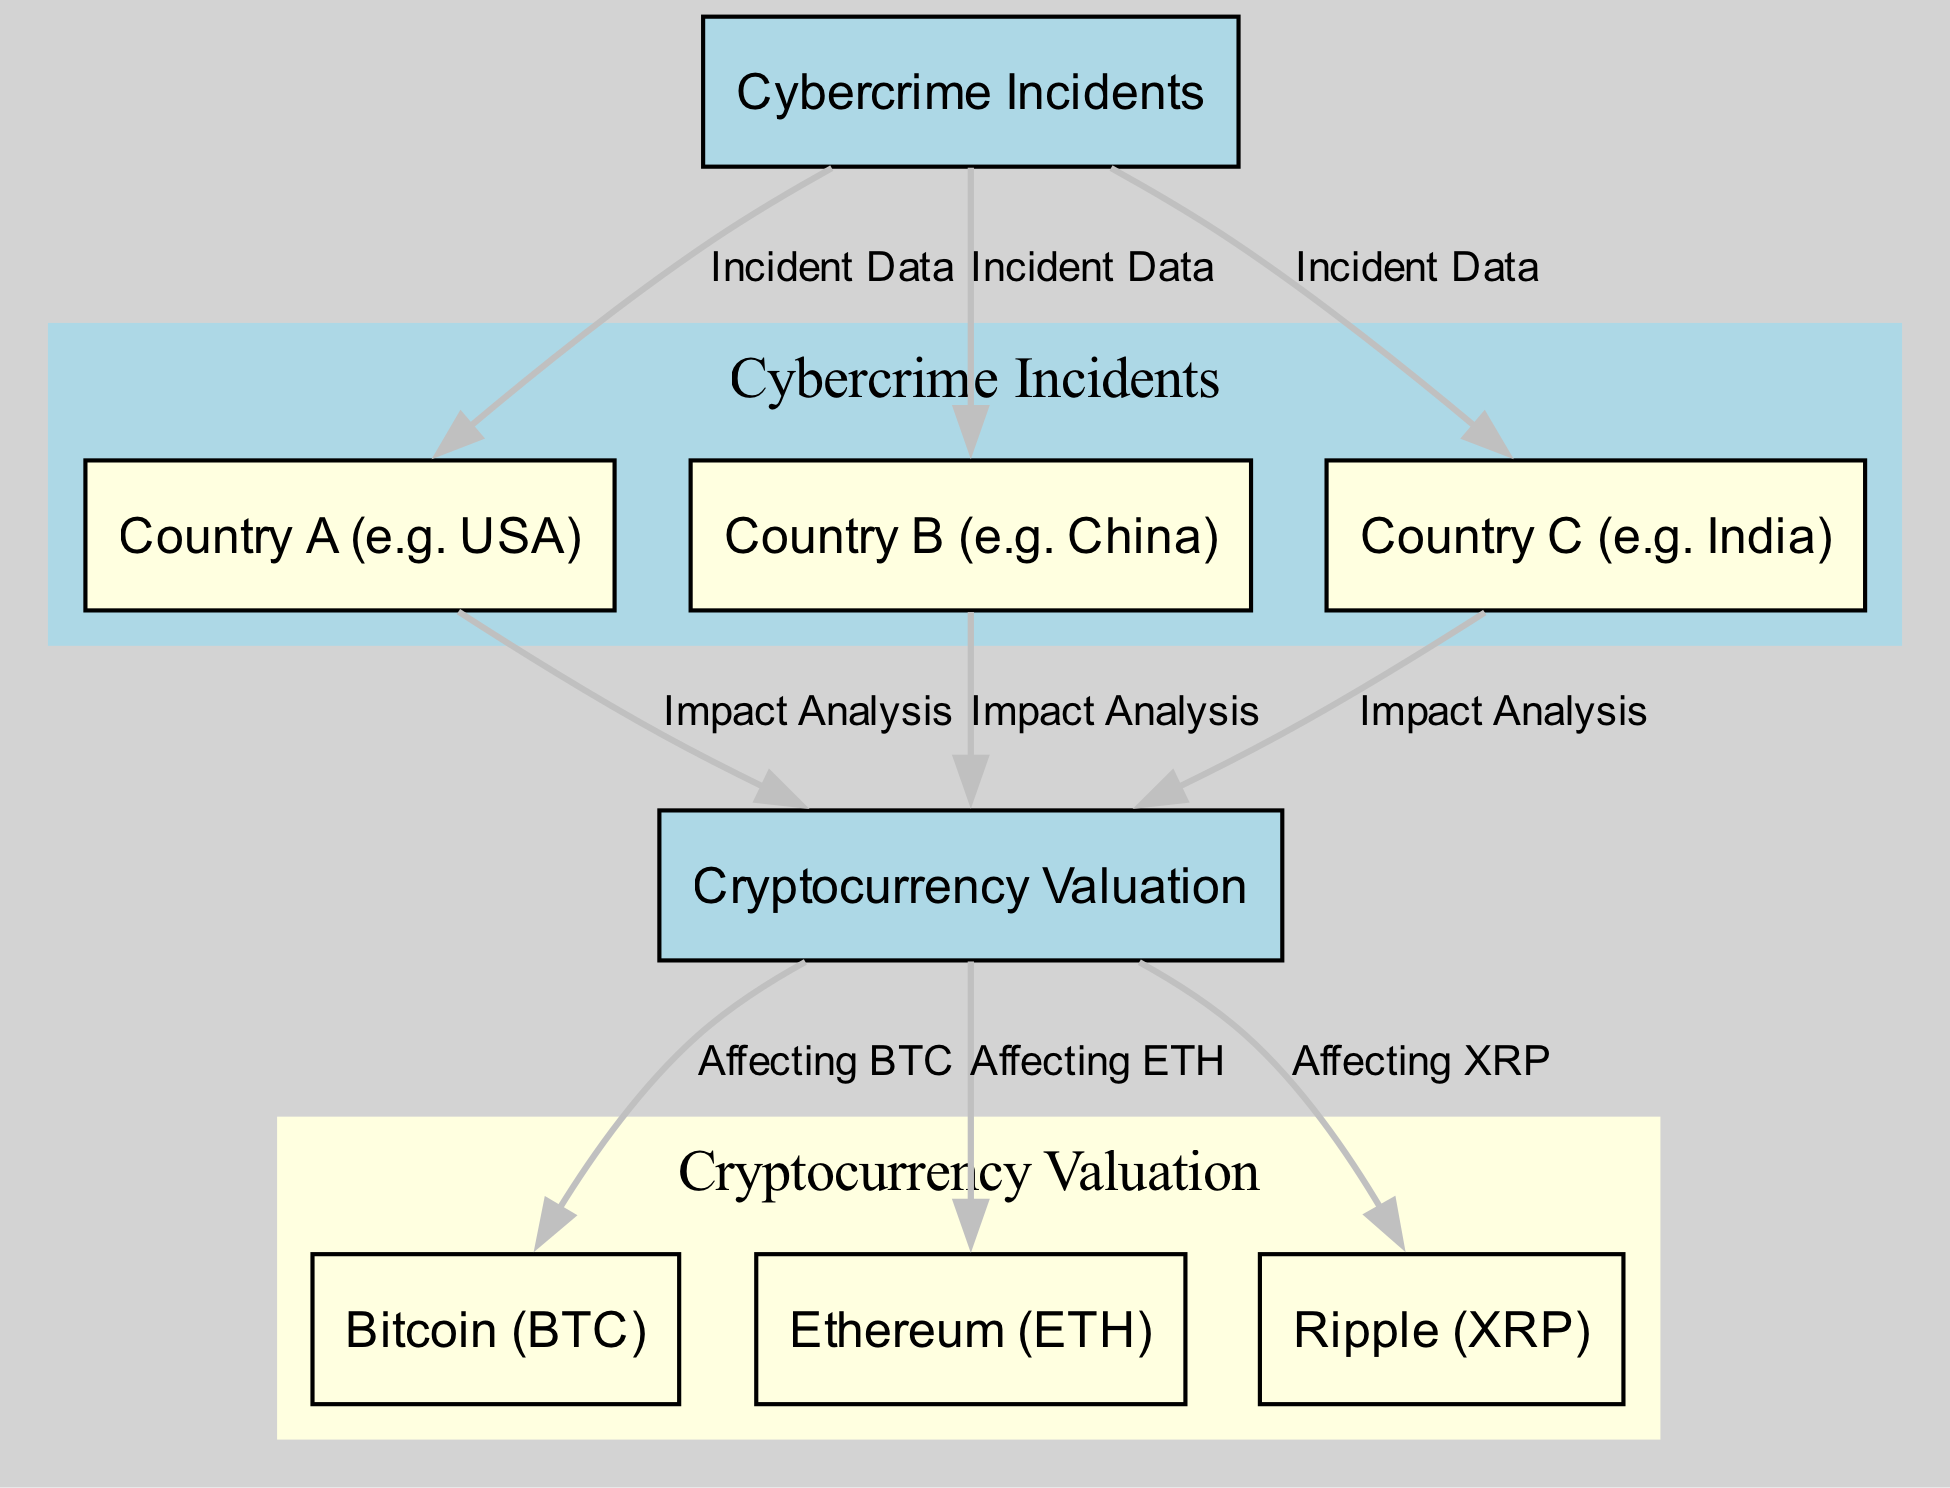What is the main category represented in the diagram? The main category node in the diagram is labeled "Cybercrime Incidents," indicating the primary focus of the analysis.
Answer: Cybercrime Incidents How many countries are represented in the diagram? There are three country nodes presented: Country A (USA), Country B (China), and Country C (India), representing a total of three countries.
Answer: 3 What is the relationship between Country A and Cryptocurrency Valuation? The edge labeled "Impact Analysis" connects Country A (USA) to Cryptocurrency Valuation, indicating that incidents in the USA impact the market valuation of cryptocurrencies.
Answer: Impact Analysis Which cryptocurrency is linked to the most nodes in the diagram? Bitcoin (BTC) is linked to "Cryptocurrency Valuation" and is affected by cybercrime incidents through the associated analysis, indicating its relevance compared to others.
Answer: Bitcoin (BTC) How do cybercrime incidents in India affect cryptocurrency valuation? The edge labeled "Impact Analysis" indicates that cybercrime incidents in India directly correlate with the evaluation of cryptocurrency valuation in that region.
Answer: Impact Analysis What is the type of the node representing Ripple? The node representing Ripple (XRP) is categorized as an "entity," meaning it represents a specific element of cryptocurrency valuation.
Answer: entity What does the edge labeled 'Affecting XRP' signify? The edge labeled 'Affecting XRP' signifies the direct impact of overall cryptocurrency valuation on Ripple's market performance.
Answer: Direct impact Which two nodes are categorized as entity types? The nodes that are categorized as entity types are Bitcoin (BTC) and Ethereum (ETH), both representing specific cryptocurrencies.
Answer: Bitcoin (BTC) and Ethereum (ETH) What is indicated by the tooltip of 'Incident Data' edges? The tooltip for 'Incident Data' edges states that they represent reported cybercrime incidents in their respective countries, providing context for the data flow.
Answer: Reported incidents 